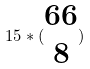Convert formula to latex. <formula><loc_0><loc_0><loc_500><loc_500>1 5 * ( \begin{matrix} 6 6 \\ 8 \end{matrix} )</formula> 